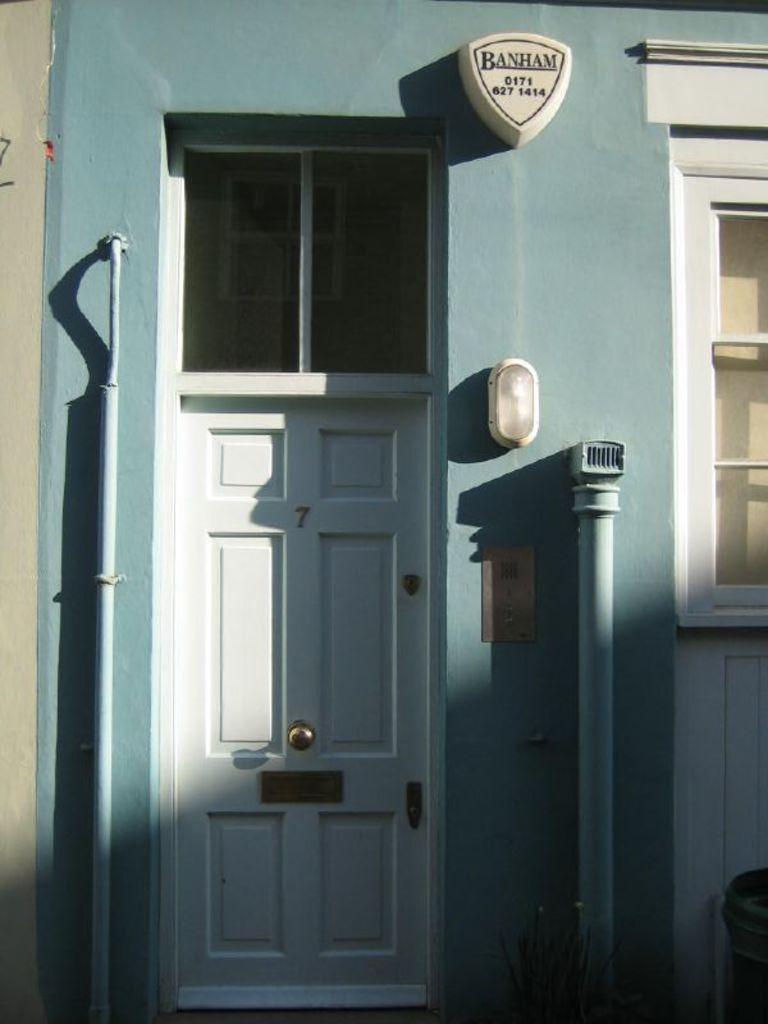Could you give a brief overview of what you see in this image? In this image I can see the wall which is blue and cream in color, two pipes and the white colored door. I can see the white colored object, a light and the window which is white in color. 